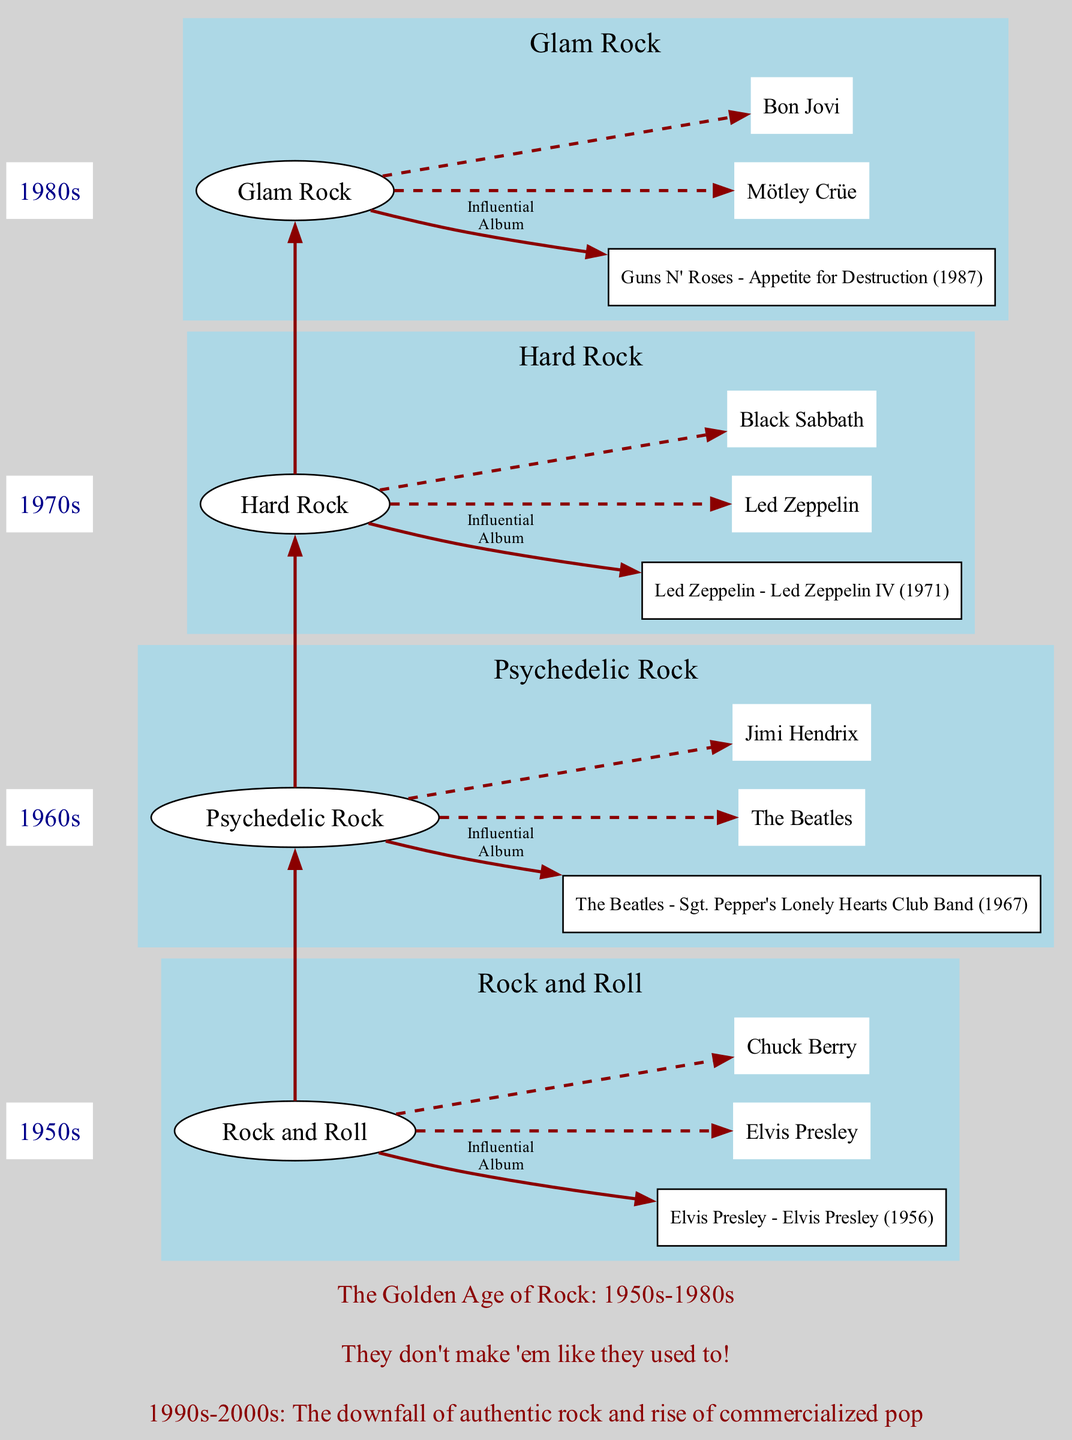What's the influential album of the 1970s? The diagram lists "Led Zeppelin - Led Zeppelin IV (1971)" as the influential album for the 1970s under the Hard Rock genre. This relationship can be found contiguous to the decade label "1970s".
Answer: Led Zeppelin - Led Zeppelin IV (1971) Who are the key artists of Glam Rock? According to the diagram, the key artists of Glam Rock in the 1980s are "Mötley Crüe" and "Bon Jovi". These artists are connected to the Glam Rock genre node under the section labeled "1980s".
Answer: Mötley Crüe, Bon Jovi Which genre is associated with The Beatles? In the diagram, The Beatles are classified under the genre "Psychedelic Rock", which is presented in the section for the 1960s. This can be determined by tracing the artist node to its respective genre in the visual structure.
Answer: Psychedelic Rock How many decades are represented in the diagram? The diagram has visual segments for four decades (1950s, 1960s, 1970s, and 1980s), each corresponding to a distinct genre. Counting these segments reveals the total number of decades represented.
Answer: 4 What genre follows Hard Rock in the timeline? The diagram connects Hard Rock directly to the next genre, which is "Glam Rock" in the 1980s. By noting the sequential edge connecting these two genres, one can determine the following genre.
Answer: Glam Rock What notable trend does the decline note refer to? The decline note in the diagram states "1990s-2000s: The downfall of authentic rock and rise of commercialized pop". This summarizes the overall trend highlighted in the note.
Answer: Downfall of authentic rock and rise of commercialized pop What is the title of the diagram? The title of the diagram is presented clearly at the top, which reads "The Golden Age of Rock: 1950s-1980s". This title encompasses the time period being discussed.
Answer: The Golden Age of Rock: 1950s-1980s What is the nostalgic quote included in the diagram? The diagram features the nostalgic quote at the bottom, which is "They don't make 'em like they used to!". This phrase captures the essence of nostalgia expressed in the diagram.
Answer: They don't make 'em like they used to! 